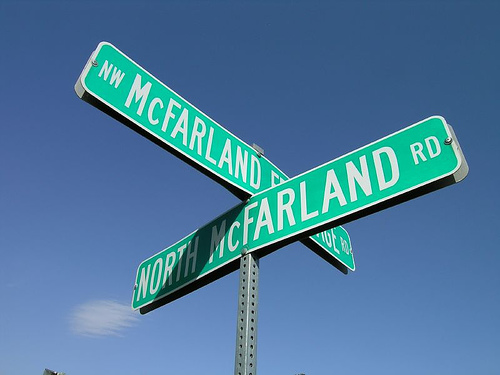<image>Where will a person be by going to the right? It is unknown where a person will be by going to the right. However, some responses suggest it could be North McFarland road or NW McFarland. Where will a person be by going to the right? I don't know where a person will be by going to the right. It can be anywhere along North McFarland Road. 